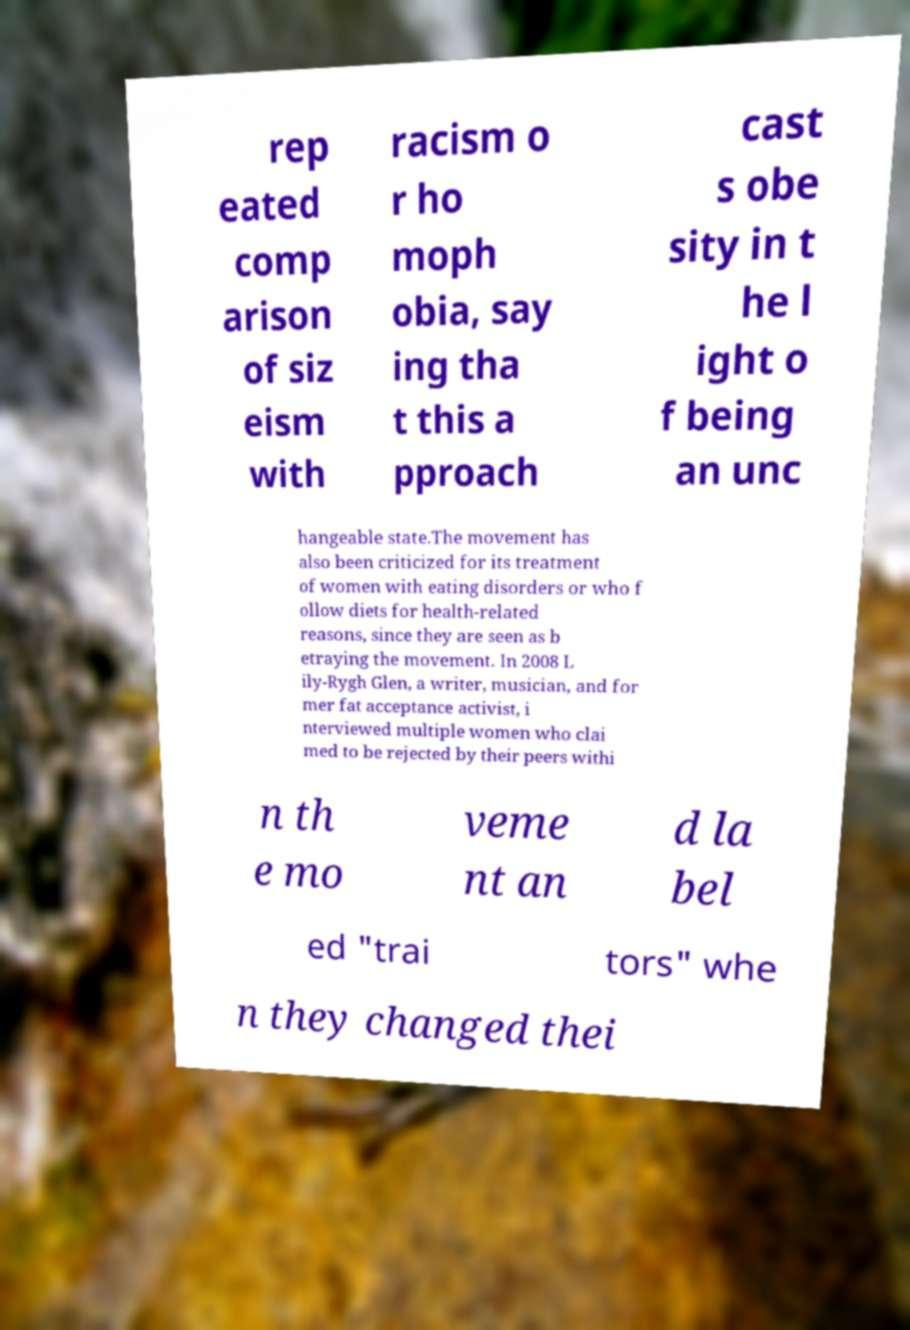I need the written content from this picture converted into text. Can you do that? rep eated comp arison of siz eism with racism o r ho moph obia, say ing tha t this a pproach cast s obe sity in t he l ight o f being an unc hangeable state.The movement has also been criticized for its treatment of women with eating disorders or who f ollow diets for health-related reasons, since they are seen as b etraying the movement. In 2008 L ily-Rygh Glen, a writer, musician, and for mer fat acceptance activist, i nterviewed multiple women who clai med to be rejected by their peers withi n th e mo veme nt an d la bel ed "trai tors" whe n they changed thei 